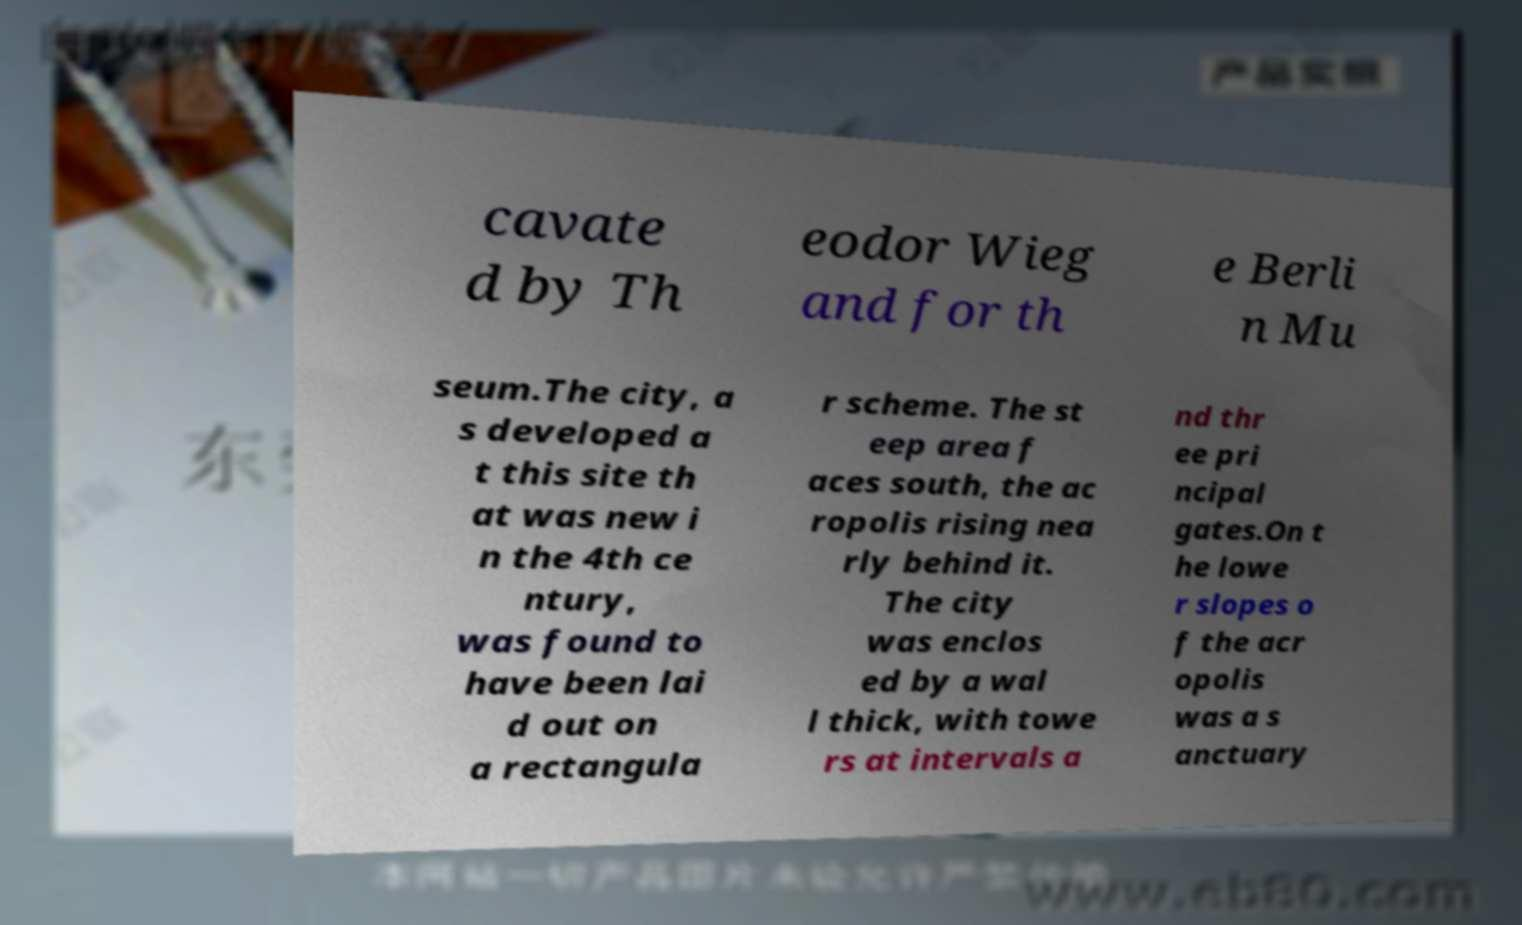Could you assist in decoding the text presented in this image and type it out clearly? cavate d by Th eodor Wieg and for th e Berli n Mu seum.The city, a s developed a t this site th at was new i n the 4th ce ntury, was found to have been lai d out on a rectangula r scheme. The st eep area f aces south, the ac ropolis rising nea rly behind it. The city was enclos ed by a wal l thick, with towe rs at intervals a nd thr ee pri ncipal gates.On t he lowe r slopes o f the acr opolis was a s anctuary 